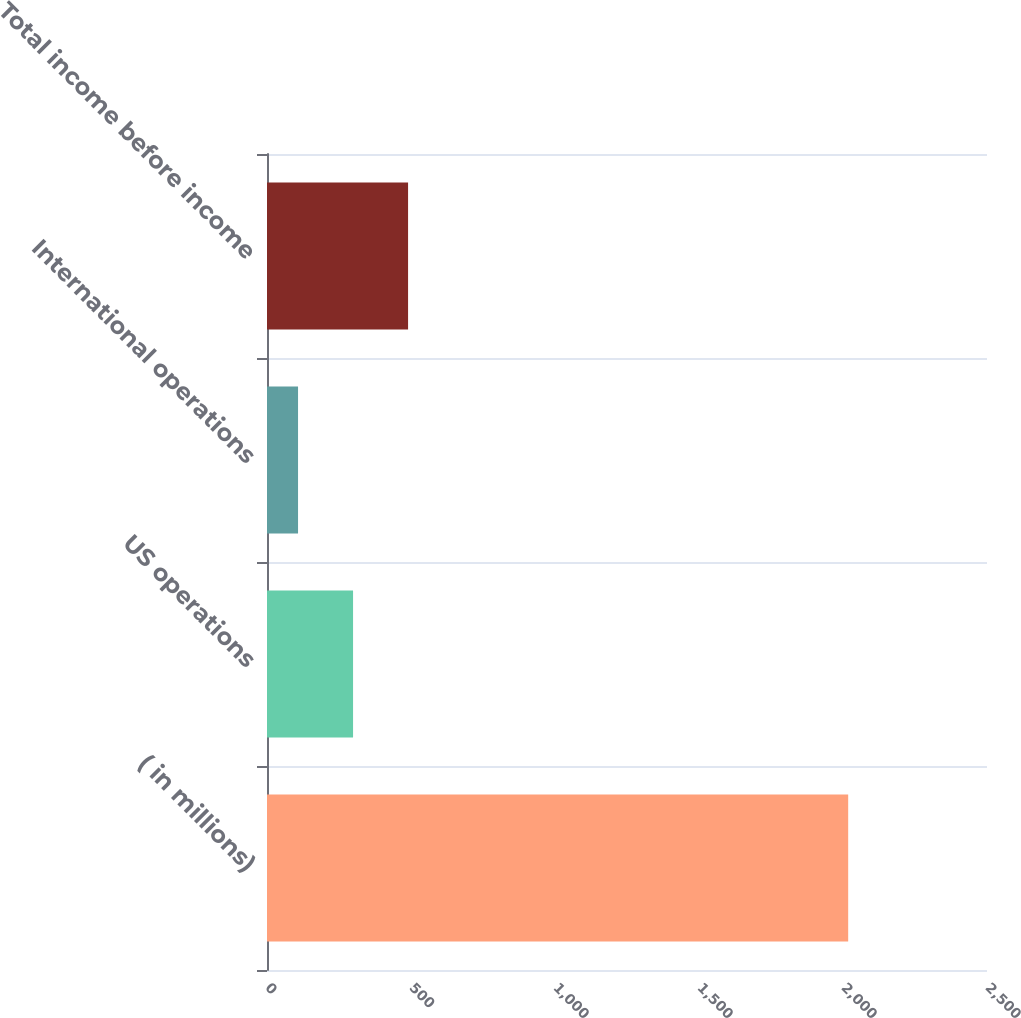<chart> <loc_0><loc_0><loc_500><loc_500><bar_chart><fcel>( in millions)<fcel>US operations<fcel>International operations<fcel>Total income before income<nl><fcel>2018<fcel>298.82<fcel>107.8<fcel>489.84<nl></chart> 